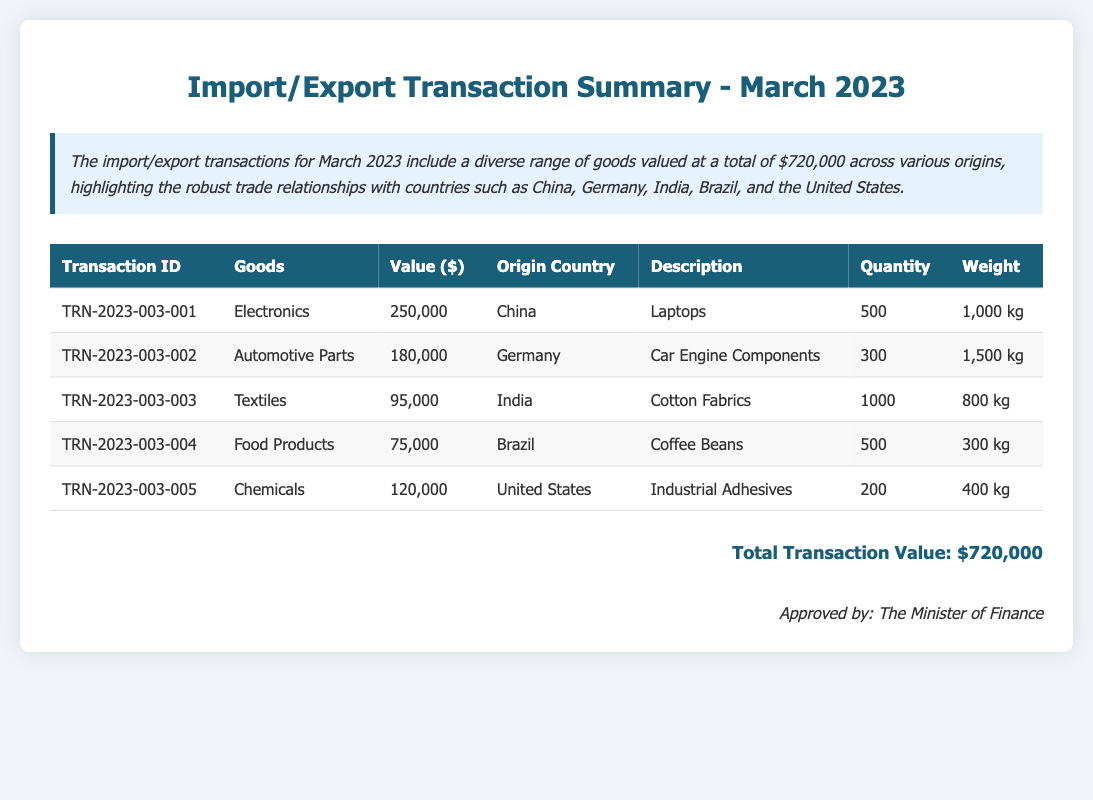What is the total transaction value? The total transaction value is stated at the bottom of the document, which sums all transactions for March 2023.
Answer: $720,000 How many goods are listed from China? The document lists one transaction for goods originating from China.
Answer: 1 What is the value of automotive parts? The value of automotive parts is specified in the table for the transaction related to automotive goods.
Answer: $180,000 What type of goods are imported from Brazil? The document specifies that food products are imported from Brazil, with a specific mention in the table.
Answer: Food Products How many kilograms do the cotton fabrics weigh? The weight of the cotton fabrics is mentioned in the details of the related transaction in the document.
Answer: 800 kg Which country has the highest transaction value? By evaluating the transaction values listed for each country, it is determined which one has the highest amount.
Answer: China What item is associated with the transaction ID TRN-2023-003-004? The document provides a specific entry that outlines the goods associated with that transaction ID.
Answer: Coffee Beans How many quantities of industrial adhesives were imported? The quantity of industrial adhesives is found in the transaction details relating to the specific goods.
Answer: 200 Which goods have the second highest value? Analyzing the values listed for each good allows for identification of the second highest transaction.
Answer: Automotive Parts 